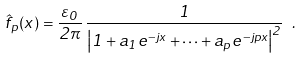<formula> <loc_0><loc_0><loc_500><loc_500>\hat { f } _ { p } ( x ) = \frac { \varepsilon _ { 0 } } { 2 \pi } \, \frac { 1 } { \left | 1 + a _ { 1 } e ^ { - j x } + \cdots + a _ { p } e ^ { - j p x } \right | ^ { 2 } } \ .</formula> 